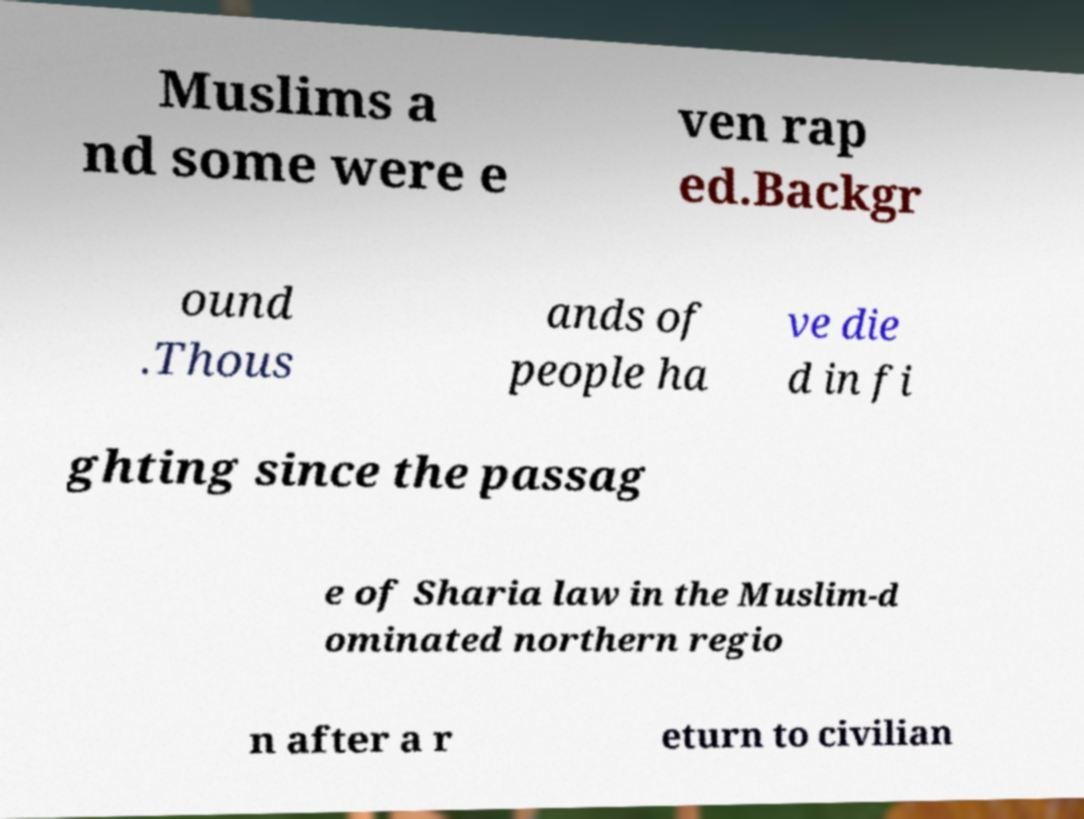I need the written content from this picture converted into text. Can you do that? Muslims a nd some were e ven rap ed.Backgr ound .Thous ands of people ha ve die d in fi ghting since the passag e of Sharia law in the Muslim-d ominated northern regio n after a r eturn to civilian 